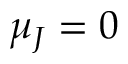Convert formula to latex. <formula><loc_0><loc_0><loc_500><loc_500>\mu _ { J } = 0</formula> 